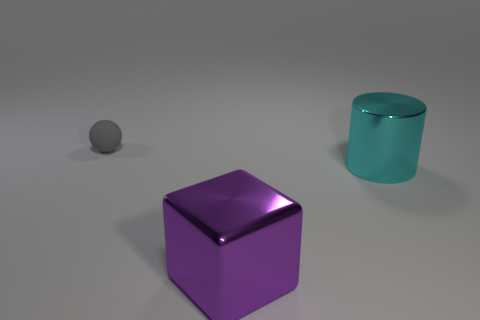Are there any other things that have the same material as the small gray sphere?
Your answer should be compact. No. There is a object left of the big purple metallic object; how big is it?
Your answer should be very brief. Small. What is the material of the small gray object?
Ensure brevity in your answer.  Rubber. There is a metallic object on the right side of the object in front of the cyan metallic object; what shape is it?
Your response must be concise. Cylinder. What number of other things are the same shape as the small matte thing?
Your answer should be compact. 0. There is a large block; are there any purple metallic objects behind it?
Provide a short and direct response. No. What color is the large shiny block?
Your answer should be very brief. Purple. Is there a cyan object of the same size as the purple cube?
Ensure brevity in your answer.  Yes. What material is the gray object behind the large shiny cylinder?
Offer a terse response. Rubber. Are there the same number of purple metal cubes right of the matte sphere and big metal cylinders that are to the left of the large purple metal thing?
Offer a very short reply. No. 